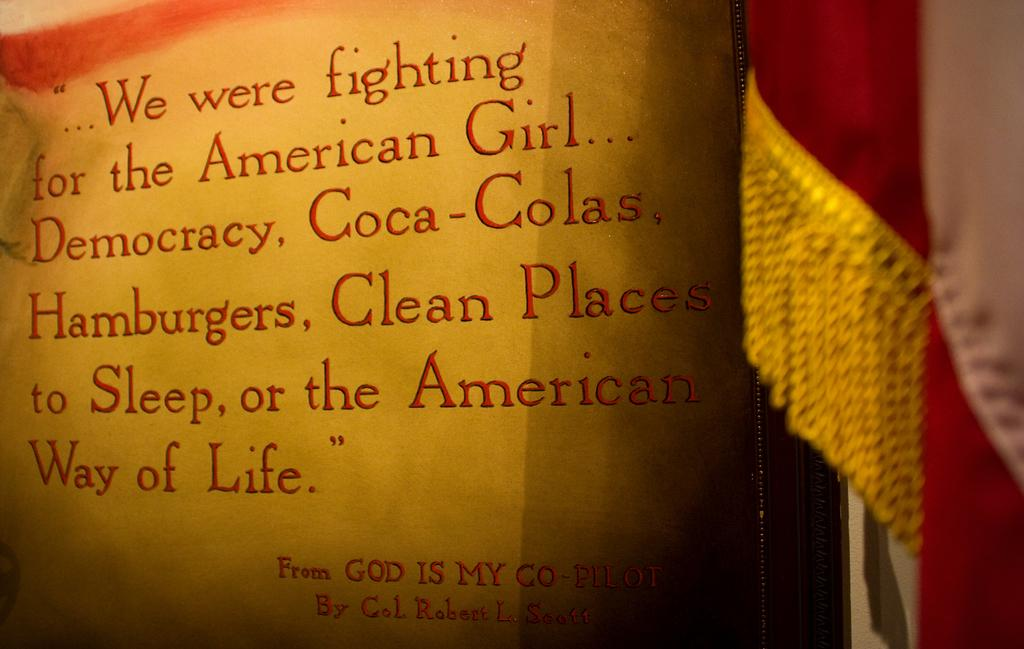<image>
Describe the image concisely. A quote from God Is My Co-Pilot explains what the author was fighting for. 